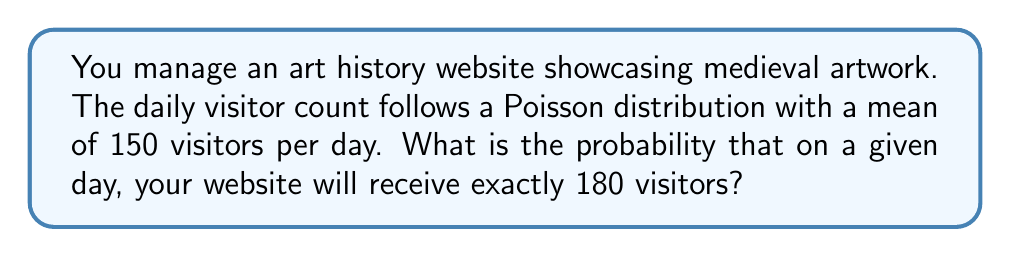Give your solution to this math problem. Let's approach this step-by-step:

1) The Poisson distribution is given by the formula:

   $$P(X = k) = \frac{e^{-\lambda} \lambda^k}{k!}$$

   Where:
   - $\lambda$ is the average number of events in the interval
   - $k$ is the number of events we're calculating the probability for
   - $e$ is Euler's number (approximately 2.71828)

2) In this case:
   - $\lambda = 150$ (average daily visitors)
   - $k = 180$ (the number of visitors we're calculating the probability for)

3) Let's substitute these values into the formula:

   $$P(X = 180) = \frac{e^{-150} 150^{180}}{180!}$$

4) This is a complex calculation, so we'll use a calculator or computer to evaluate it:

   $$P(X = 180) \approx 0.00516$$

5) To interpret this result: There is approximately a 0.516% chance that the website will receive exactly 180 visitors on a given day.

This low probability is expected, as 180 is significantly higher than the mean of 150, and the Poisson distribution becomes increasingly unlikely for values far from the mean.
Answer: 0.00516 or 0.516% 